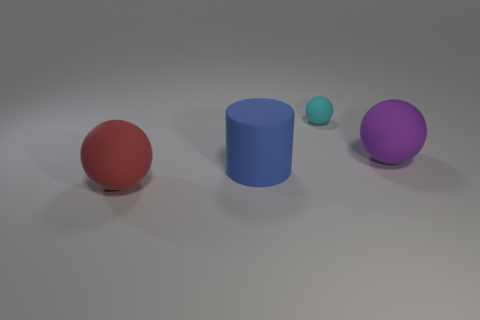The purple thing that is the same shape as the big red rubber thing is what size?
Ensure brevity in your answer.  Large. Do the large object that is to the right of the blue object and the small object have the same shape?
Make the answer very short. Yes. There is a object to the right of the cyan sphere; what is its material?
Offer a very short reply. Rubber. Is the number of tiny cyan matte balls that are on the left side of the large blue cylinder greater than the number of small gray metal objects?
Provide a succinct answer. No. Are there any small cyan rubber things that are on the left side of the large ball that is in front of the big thing behind the blue matte cylinder?
Ensure brevity in your answer.  No. Are there any rubber things to the right of the large cylinder?
Offer a very short reply. Yes. What is the size of the purple sphere that is the same material as the cylinder?
Your answer should be very brief. Large. What is the size of the ball in front of the big ball that is behind the sphere that is in front of the blue thing?
Give a very brief answer. Large. What is the size of the sphere in front of the big purple object?
Ensure brevity in your answer.  Large. What number of red objects are big rubber cylinders or large rubber spheres?
Ensure brevity in your answer.  1. 